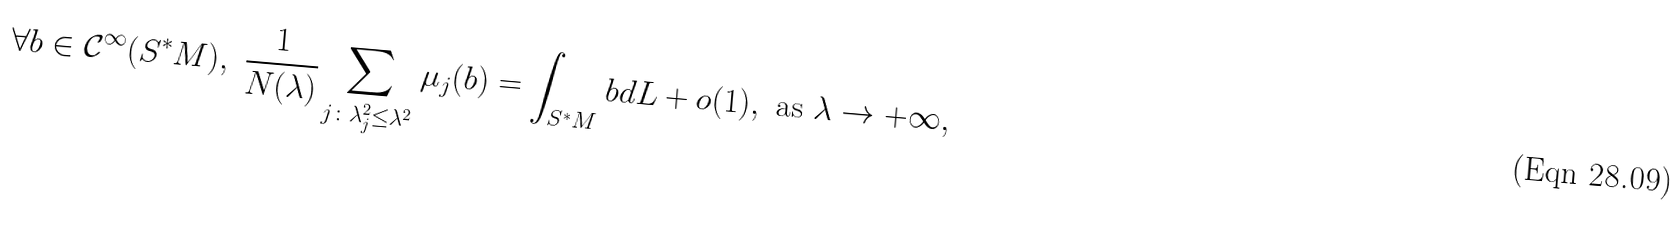Convert formula to latex. <formula><loc_0><loc_0><loc_500><loc_500>\forall b \in \mathcal { C } ^ { \infty } ( S ^ { * } M ) , \ \frac { 1 } { N ( \lambda ) } \sum _ { j \colon \lambda _ { j } ^ { 2 } \leq \lambda ^ { 2 } } \mu _ { j } ( b ) = \int _ { S ^ { * } M } b d L + o ( 1 ) , \ \text {as} \ \lambda \rightarrow + \infty ,</formula> 